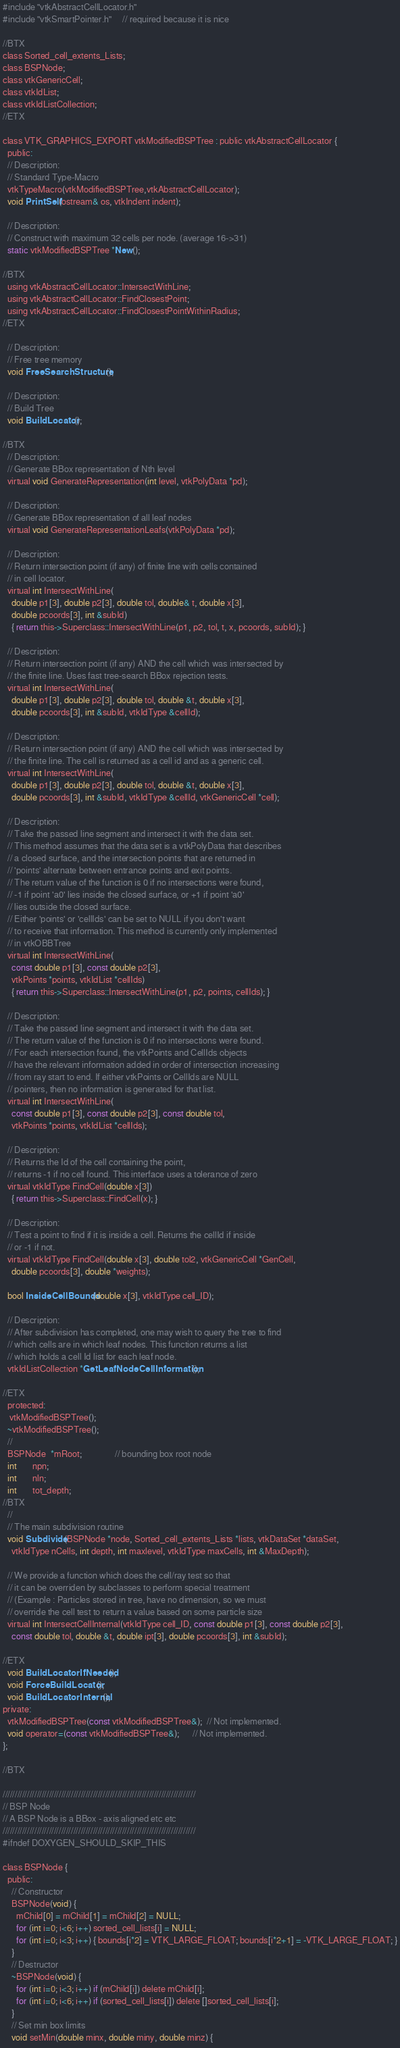Convert code to text. <code><loc_0><loc_0><loc_500><loc_500><_C_>
#include "vtkAbstractCellLocator.h"
#include "vtkSmartPointer.h"     // required because it is nice

//BTX
class Sorted_cell_extents_Lists;
class BSPNode;
class vtkGenericCell;
class vtkIdList;
class vtkIdListCollection;
//ETX

class VTK_GRAPHICS_EXPORT vtkModifiedBSPTree : public vtkAbstractCellLocator {
  public:
  // Description:
  // Standard Type-Macro
  vtkTypeMacro(vtkModifiedBSPTree,vtkAbstractCellLocator);
  void PrintSelf(ostream& os, vtkIndent indent);

  // Description:
  // Construct with maximum 32 cells per node. (average 16->31)
  static vtkModifiedBSPTree *New();

//BTX
  using vtkAbstractCellLocator::IntersectWithLine;
  using vtkAbstractCellLocator::FindClosestPoint;
  using vtkAbstractCellLocator::FindClosestPointWithinRadius;
//ETX

  // Description:
  // Free tree memory
  void FreeSearchStructure();

  // Description:
  // Build Tree
  void BuildLocator();

//BTX
  // Description:
  // Generate BBox representation of Nth level
  virtual void GenerateRepresentation(int level, vtkPolyData *pd);

  // Description:
  // Generate BBox representation of all leaf nodes
  virtual void GenerateRepresentationLeafs(vtkPolyData *pd);

  // Description:
  // Return intersection point (if any) of finite line with cells contained
  // in cell locator.
  virtual int IntersectWithLine(
    double p1[3], double p2[3], double tol, double& t, double x[3],
    double pcoords[3], int &subId)
    { return this->Superclass::IntersectWithLine(p1, p2, tol, t, x, pcoords, subId); }

  // Description:
  // Return intersection point (if any) AND the cell which was intersected by
  // the finite line. Uses fast tree-search BBox rejection tests.
  virtual int IntersectWithLine(
    double p1[3], double p2[3], double tol, double &t, double x[3],
    double pcoords[3], int &subId, vtkIdType &cellId);

  // Description:
  // Return intersection point (if any) AND the cell which was intersected by
  // the finite line. The cell is returned as a cell id and as a generic cell.
  virtual int IntersectWithLine(
    double p1[3], double p2[3], double tol, double &t, double x[3],
    double pcoords[3], int &subId, vtkIdType &cellId, vtkGenericCell *cell);

  // Description:
  // Take the passed line segment and intersect it with the data set.
  // This method assumes that the data set is a vtkPolyData that describes
  // a closed surface, and the intersection points that are returned in
  // 'points' alternate between entrance points and exit points.
  // The return value of the function is 0 if no intersections were found,
  // -1 if point 'a0' lies inside the closed surface, or +1 if point 'a0'
  // lies outside the closed surface.
  // Either 'points' or 'cellIds' can be set to NULL if you don't want
  // to receive that information. This method is currently only implemented
  // in vtkOBBTree
  virtual int IntersectWithLine(
    const double p1[3], const double p2[3],
    vtkPoints *points, vtkIdList *cellIds)
    { return this->Superclass::IntersectWithLine(p1, p2, points, cellIds); }

  // Description:
  // Take the passed line segment and intersect it with the data set.
  // The return value of the function is 0 if no intersections were found.
  // For each intersection found, the vtkPoints and CellIds objects
  // have the relevant information added in order of intersection increasing
  // from ray start to end. If either vtkPoints or CellIds are NULL
  // pointers, then no information is generated for that list.
  virtual int IntersectWithLine(
    const double p1[3], const double p2[3], const double tol,
    vtkPoints *points, vtkIdList *cellIds);

  // Description:
  // Returns the Id of the cell containing the point,
  // returns -1 if no cell found. This interface uses a tolerance of zero
  virtual vtkIdType FindCell(double x[3])
    { return this->Superclass::FindCell(x); }

  // Description:
  // Test a point to find if it is inside a cell. Returns the cellId if inside
  // or -1 if not.
  virtual vtkIdType FindCell(double x[3], double tol2, vtkGenericCell *GenCell,
    double pcoords[3], double *weights);

  bool InsideCellBounds(double x[3], vtkIdType cell_ID);

  // Description:
  // After subdivision has completed, one may wish to query the tree to find
  // which cells are in which leaf nodes. This function returns a list
  // which holds a cell Id list for each leaf node.
  vtkIdListCollection *GetLeafNodeCellInformation();

//ETX
  protected:
   vtkModifiedBSPTree();
  ~vtkModifiedBSPTree();
  //
  BSPNode  *mRoot;               // bounding box root node
  int       npn;
  int       nln;
  int       tot_depth;
//BTX
  //
  // The main subdivision routine
  void Subdivide(BSPNode *node, Sorted_cell_extents_Lists *lists, vtkDataSet *dataSet,
    vtkIdType nCells, int depth, int maxlevel, vtkIdType maxCells, int &MaxDepth);

  // We provide a function which does the cell/ray test so that
  // it can be overriden by subclasses to perform special treatment
  // (Example : Particles stored in tree, have no dimension, so we must
  // override the cell test to return a value based on some particle size
  virtual int IntersectCellInternal(vtkIdType cell_ID, const double p1[3], const double p2[3],
    const double tol, double &t, double ipt[3], double pcoords[3], int &subId);

//ETX
  void BuildLocatorIfNeeded();
  void ForceBuildLocator();
  void BuildLocatorInternal();
private:
  vtkModifiedBSPTree(const vtkModifiedBSPTree&);  // Not implemented.
  void operator=(const vtkModifiedBSPTree&);      // Not implemented.
};

//BTX

///////////////////////////////////////////////////////////////////////////////
// BSP Node
// A BSP Node is a BBox - axis aligned etc etc
///////////////////////////////////////////////////////////////////////////////
#ifndef DOXYGEN_SHOULD_SKIP_THIS

class BSPNode {
  public:
    // Constructor
    BSPNode(void) {
      mChild[0] = mChild[1] = mChild[2] = NULL;
      for (int i=0; i<6; i++) sorted_cell_lists[i] = NULL;
      for (int i=0; i<3; i++) { bounds[i*2] = VTK_LARGE_FLOAT; bounds[i*2+1] = -VTK_LARGE_FLOAT; }
    }
    // Destructor
    ~BSPNode(void) {
      for (int i=0; i<3; i++) if (mChild[i]) delete mChild[i];
      for (int i=0; i<6; i++) if (sorted_cell_lists[i]) delete []sorted_cell_lists[i];
    }
    // Set min box limits
    void setMin(double minx, double miny, double minz) {</code> 